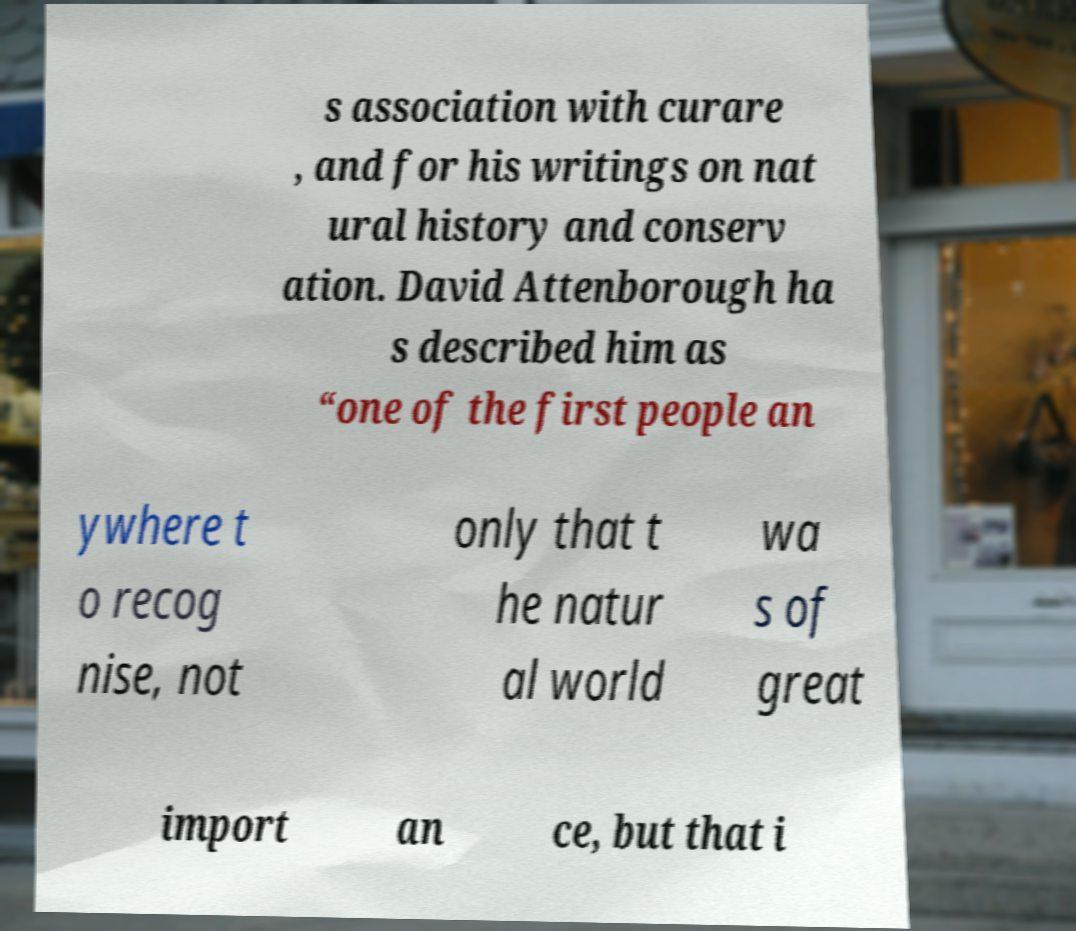Could you assist in decoding the text presented in this image and type it out clearly? s association with curare , and for his writings on nat ural history and conserv ation. David Attenborough ha s described him as “one of the first people an ywhere t o recog nise, not only that t he natur al world wa s of great import an ce, but that i 